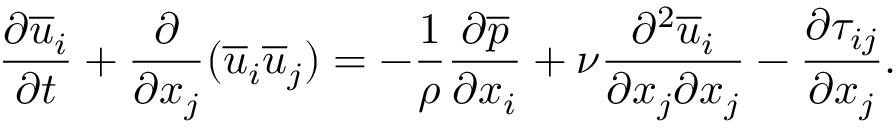Convert formula to latex. <formula><loc_0><loc_0><loc_500><loc_500>\frac { \partial \overline { u } _ { i } } { \partial t } + \frac { \partial } { \partial x _ { j } } ( \overline { u } _ { i } \overline { u } _ { j } ) = - \frac { 1 } { \rho } \frac { \partial \overline { p } } { \partial x _ { i } } + \nu \frac { \partial ^ { 2 } \overline { u } _ { i } } { \partial x _ { j } \partial x _ { j } } - \frac { \partial \tau _ { i j } } { \partial x _ { j } } .</formula> 